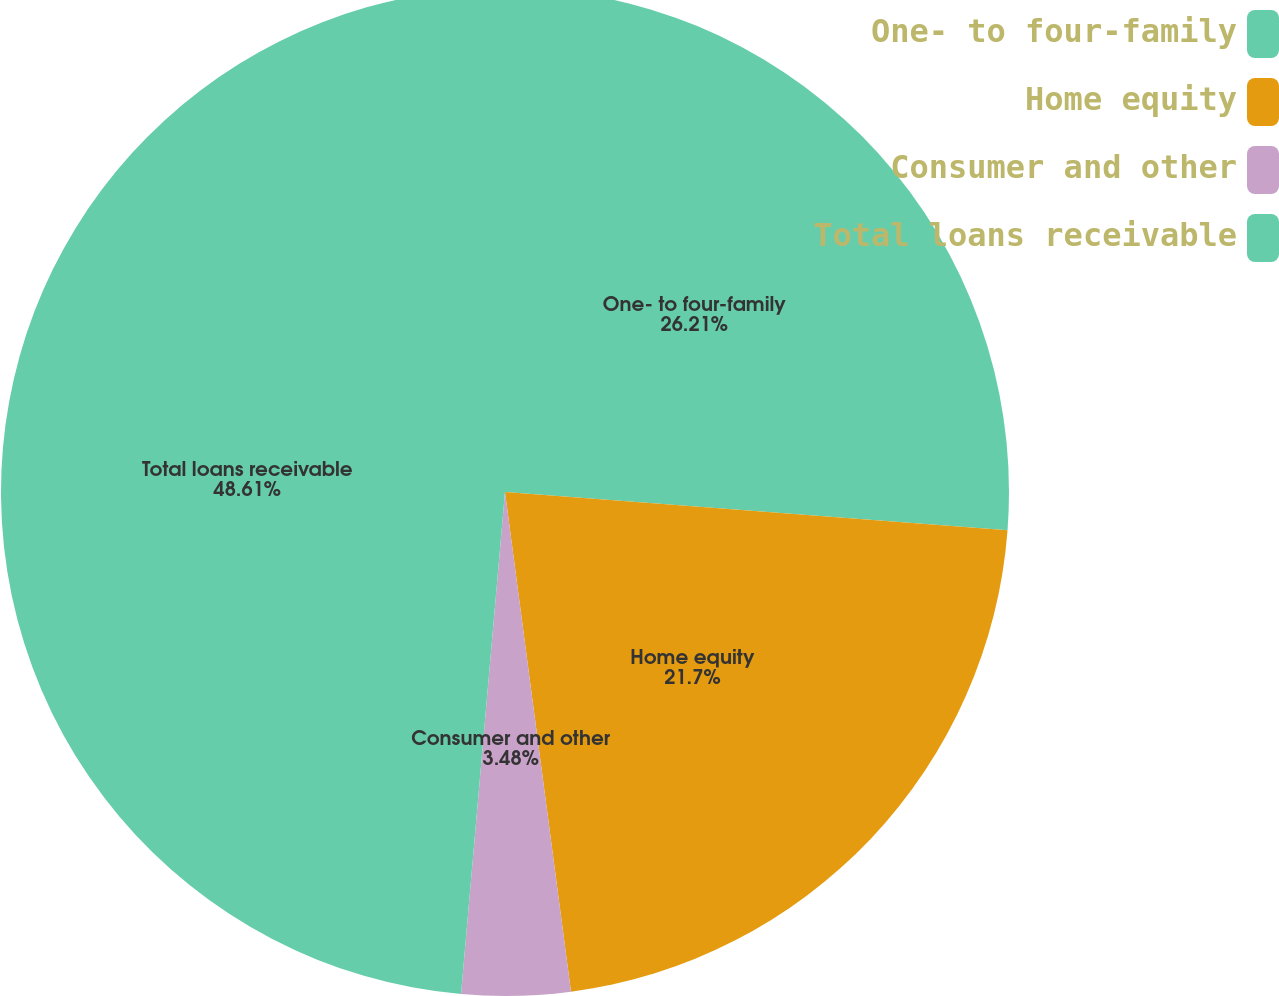Convert chart. <chart><loc_0><loc_0><loc_500><loc_500><pie_chart><fcel>One- to four-family<fcel>Home equity<fcel>Consumer and other<fcel>Total loans receivable<nl><fcel>26.21%<fcel>21.7%<fcel>3.48%<fcel>48.61%<nl></chart> 